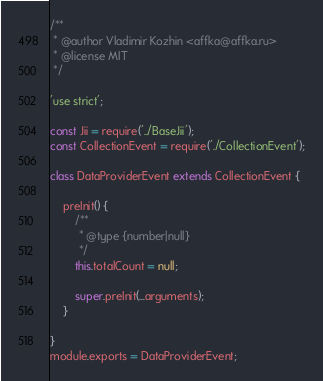Convert code to text. <code><loc_0><loc_0><loc_500><loc_500><_JavaScript_>/**
 * @author Vladimir Kozhin <affka@affka.ru>
 * @license MIT
 */

'use strict';

const Jii = require('../BaseJii');
const CollectionEvent = require('./CollectionEvent');

class DataProviderEvent extends CollectionEvent {

    preInit() {
        /**
         * @type {number|null}
         */
        this.totalCount = null;

        super.preInit(...arguments);
    }

}
module.exports = DataProviderEvent;</code> 